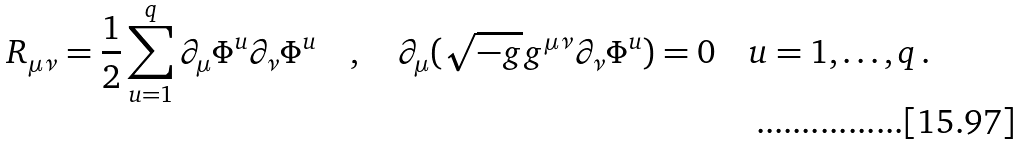<formula> <loc_0><loc_0><loc_500><loc_500>R _ { \mu \nu } = \frac { 1 } { 2 } \sum _ { u = 1 } ^ { q } \partial _ { \mu } \Phi ^ { u } \partial _ { \nu } \Phi ^ { u } \quad , \quad \partial _ { \mu } ( \sqrt { - g } g ^ { \mu \nu } \partial _ { \nu } \Phi ^ { u } ) = 0 \quad u = 1 , \dots , q \, .</formula> 